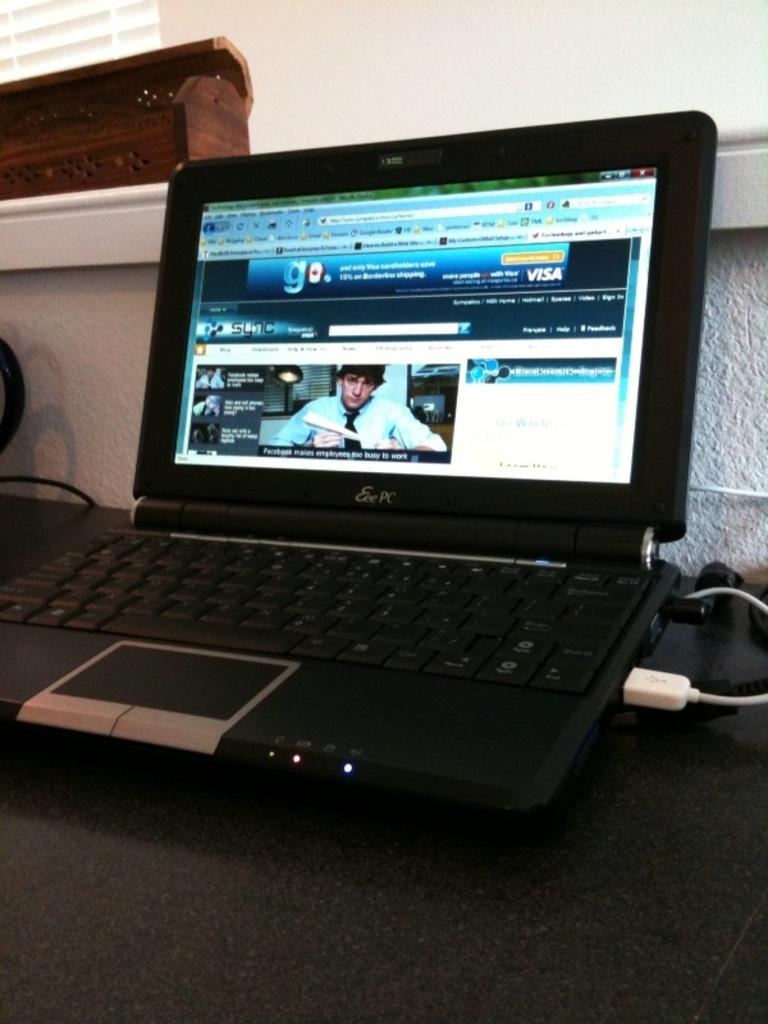<image>
Present a compact description of the photo's key features. The screen for the Eee PC displays an article claiming that Facebook makes employees to busy to work. 